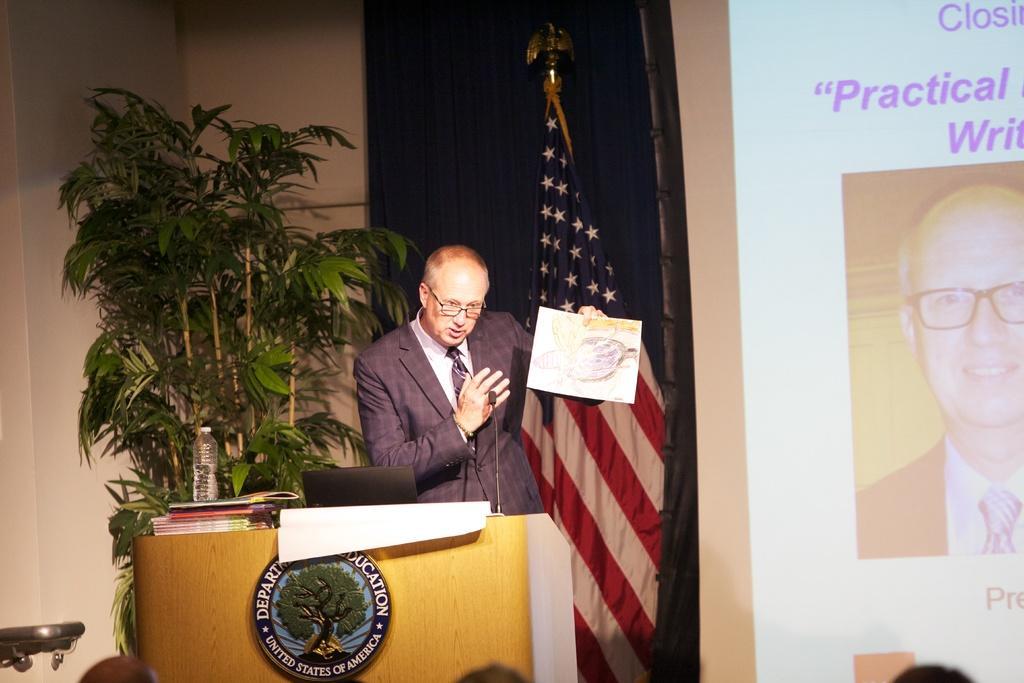In one or two sentences, can you explain what this image depicts? In this image there is a man standing near the podium by holding the paper. In front of him there is a mic. On the podium there are books,laptop and a water bottle. In the background there is a flag. On the left side there is a plant. On the right side there is a screen. 